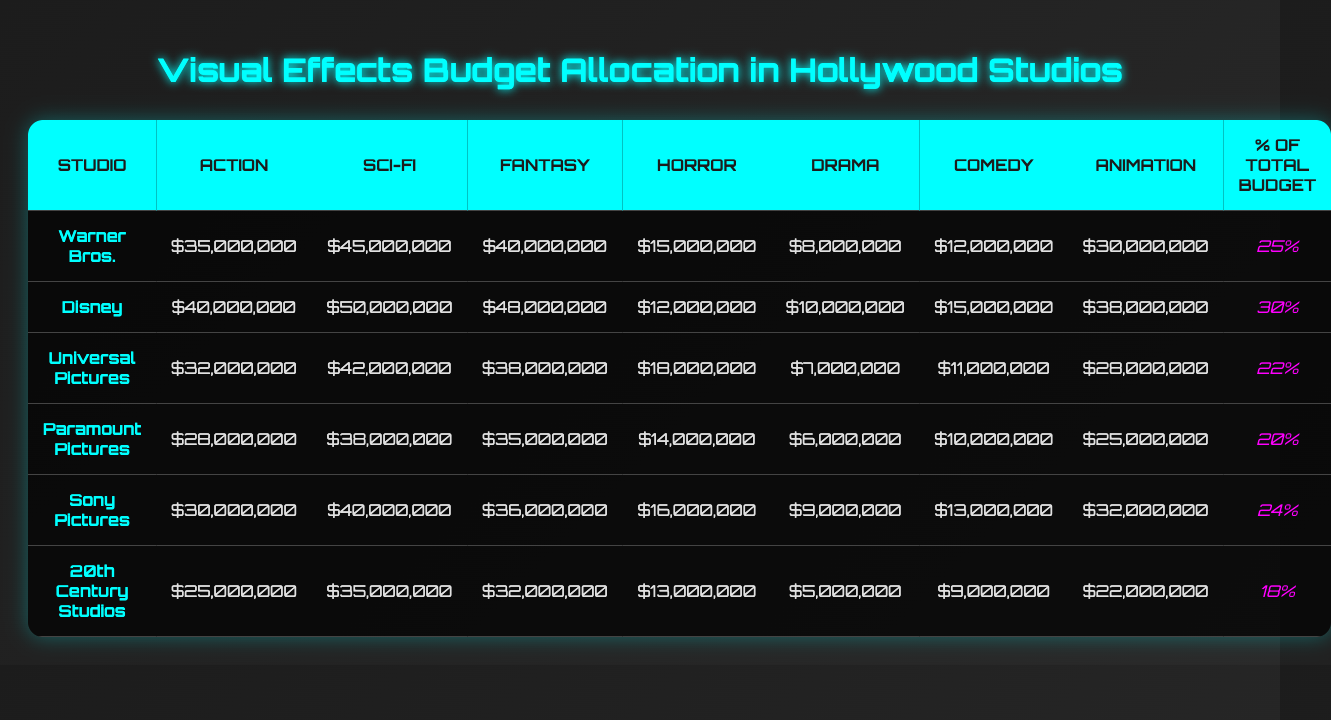What studio allocated the most budget for Action films? By comparing the Action budgets across all studios, Warner Bros. has the highest allocation, with $35,000,000.
Answer: Warner Bros Which genre received the least amount of budget overall? By reviewing the budget allocations for each genre, Horror has the smallest total allocation across all studios, with a maximum of $18,000,000 for Universal Pictures.
Answer: Horror What is the total budget allocated for Sci-Fi films across all studios? By summing up the Sci-Fi budgets: $45,000,000 + $50,000,000 + $42,000,000 + $38,000,000 + $40,000,000 + $35,000,000 = $250,000,000.
Answer: $250,000,000 How much more does Disney spend on Action films compared to Sony Pictures? The Action budget for Disney is $40,000,000 and for Sony Pictures, it's $30,000,000. The difference is $40,000,000 - $30,000,000 = $10,000,000.
Answer: $10,000,000 Which studio has the highest percentage of its total budget allocated to Animation? By reviewing the Percentage of Total Budget column, Disney allocates 30% to Animation, which is the highest percentage.
Answer: Disney Is the budget for Drama films higher than that for Horror films across all studios? Comparing the budgets, Drama has a maximum of $10,000,000 (Disney) while Horror has a maximum of $18,000,000 (Universal Pictures). Thus, Drama is lower.
Answer: No What is the average budget for Fantasy films across all the studios? To find the average, sum the Fantasy budgets ($40,000,000 + $48,000,000 + $38,000,000 + $35,000,000 + $36,000,000 + $32,000,000 = $219,000,000) and then divide by 6, resulting in an average of $36,500,000.
Answer: $36,500,000 Which studio has the lowest total budget allocation across all genres combined? By adding up the budgets for all films from each studio, 20th Century Studios has the lowest total: $25,000,000 + $35,000,000 + $32,000,000 + $13,000,000 + $5,000,000 + $9,000,000 + $22,000,000 = $136,000,000.
Answer: 20th Century Studios How do the Animation budgets of Warner Bros. and Universal Pictures compare? Warner Bros. allocated $30,000,000 for Animation while Universal Pictures allocated $28,000,000. Warner Bros. spends more.
Answer: Warner Bros. spends more What is the difference in budget allocation for Comedy films between the highest and lowest studios? Disney allocates $15,000,000 for Comedy, while 20th Century Studios allocates $9,000,000. The difference is $15,000,000 - $9,000,000 = $6,000,000.
Answer: $6,000,000 